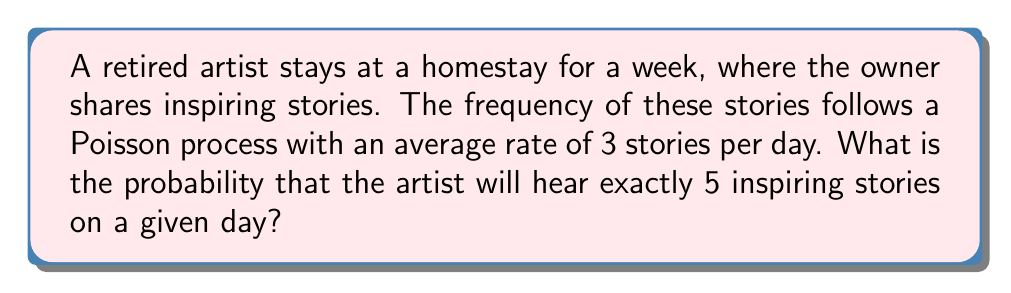Could you help me with this problem? To solve this problem, we'll use the Poisson distribution formula:

$$P(X = k) = \frac{e^{-\lambda} \lambda^k}{k!}$$

Where:
$\lambda$ = average rate of events (stories per day)
$k$ = number of events (stories) we're interested in
$e$ = Euler's number (approximately 2.71828)

Given:
$\lambda = 3$ stories per day
$k = 5$ stories

Let's substitute these values into the formula:

$$P(X = 5) = \frac{e^{-3} 3^5}{5!}$$

Now, let's calculate step-by-step:

1) First, calculate $e^{-3}$:
   $e^{-3} \approx 0.0497871$

2) Calculate $3^5$:
   $3^5 = 243$

3) Calculate $5!$:
   $5! = 5 \times 4 \times 3 \times 2 \times 1 = 120$

4) Substitute these values into the formula:
   $$P(X = 5) = \frac{0.0497871 \times 243}{120}$$

5) Perform the final calculation:
   $$P(X = 5) \approx 0.1008$$

Therefore, the probability of hearing exactly 5 inspiring stories on a given day is approximately 0.1008 or 10.08%.
Answer: 0.1008 